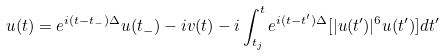Convert formula to latex. <formula><loc_0><loc_0><loc_500><loc_500>u ( t ) = e ^ { i ( t - t _ { - } ) \Delta } u ( t _ { - } ) - i v ( t ) - i \int _ { t _ { j } } ^ { t } e ^ { i ( t - t ^ { \prime } ) \Delta } [ | u ( t ^ { \prime } ) | ^ { 6 } u ( t ^ { \prime } ) ] d t ^ { \prime }</formula> 